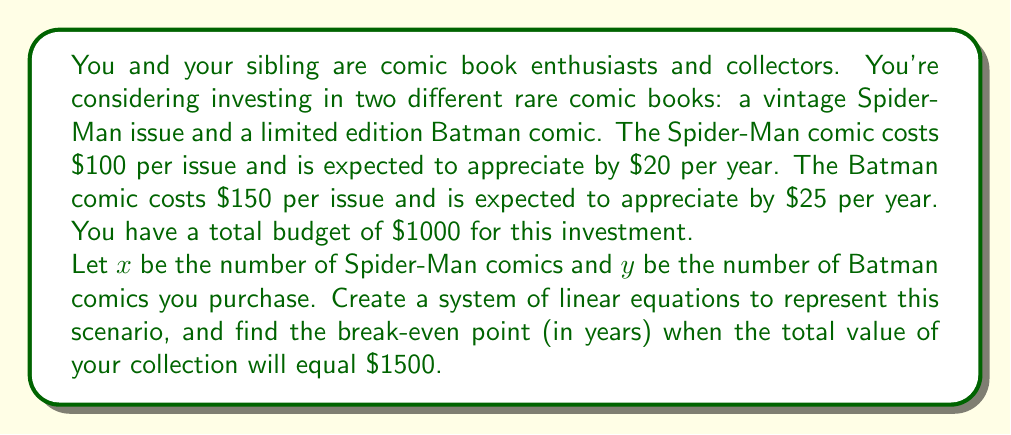What is the answer to this math problem? Let's approach this step-by-step:

1) First, we need to create two equations based on the given information:

   a) Budget constraint: $100x + 150y = 1000$
   b) Future value equation: $(100 + 20t)x + (150 + 25t)y = 1500$, where $t$ is time in years

2) From the budget constraint, we can express $y$ in terms of $x$:
   $y = \frac{1000 - 100x}{150} = \frac{20 - 2x}{3}$

3) Substitute this into the future value equation:
   $(100 + 20t)x + (150 + 25t)(\frac{20 - 2x}{3}) = 1500$

4) Simplify:
   $(100 + 20t)x + (1000 + \frac{500t}{3}) - (100 + \frac{50t}{3})x = 1500$

5) Combine like terms:
   $(100 + 20t - 100 - \frac{50t}{3})x = 1500 - 1000 - \frac{500t}{3}$

6) Simplify further:
   $(20t - \frac{50t}{3})x = 500 - \frac{500t}{3}$

7) Multiply both sides by 3:
   $(60t - 50t)x = 1500 - 500t$

8) Simplify:
   $10tx = 1500 - 500t$

9) Solve for $t$:
   $500t + 10tx = 1500$
   $t(500 + 10x) = 1500$
   $t = \frac{1500}{500 + 10x}$

10) Remember, $x$ must be a whole number and satisfy the budget constraint. The only integer value that works is $x = 5$ (and consequently, $y = \frac{20 - 2(5)}{3} = \frac{10}{3} \approx 3$).

11) Substitute $x = 5$ into the equation for $t$:
    $t = \frac{1500}{500 + 10(5)} = \frac{1500}{550} = \frac{150}{55} \approx 2.73$ years
Answer: The break-even point is approximately 2.73 years, or 2 years and 8.7 months. 